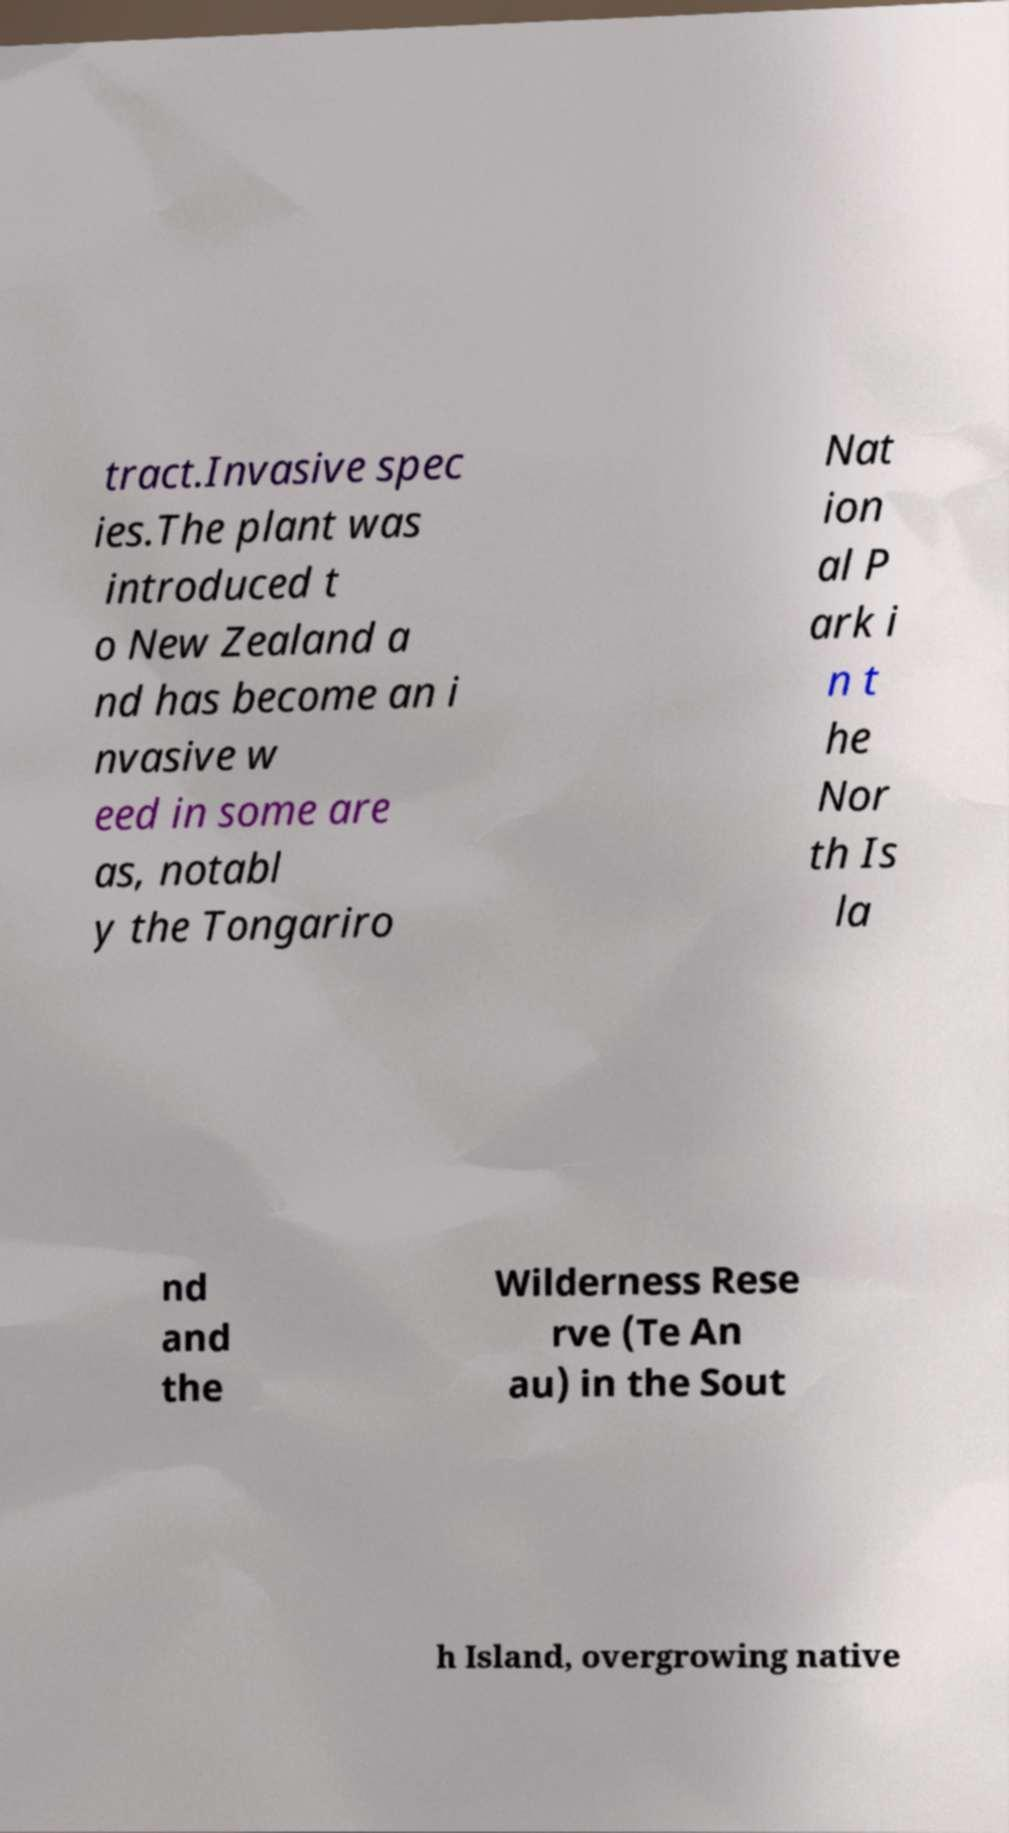Could you assist in decoding the text presented in this image and type it out clearly? tract.Invasive spec ies.The plant was introduced t o New Zealand a nd has become an i nvasive w eed in some are as, notabl y the Tongariro Nat ion al P ark i n t he Nor th Is la nd and the Wilderness Rese rve (Te An au) in the Sout h Island, overgrowing native 